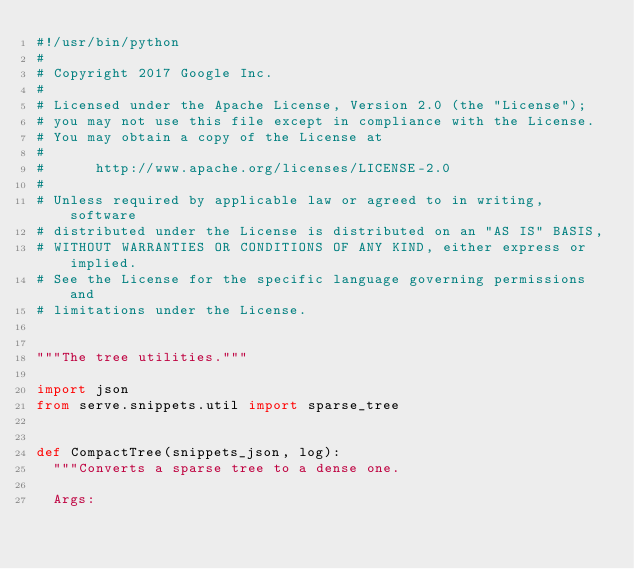Convert code to text. <code><loc_0><loc_0><loc_500><loc_500><_Python_>#!/usr/bin/python
#
# Copyright 2017 Google Inc.
#
# Licensed under the Apache License, Version 2.0 (the "License");
# you may not use this file except in compliance with the License.
# You may obtain a copy of the License at
#
#      http://www.apache.org/licenses/LICENSE-2.0
#
# Unless required by applicable law or agreed to in writing, software
# distributed under the License is distributed on an "AS IS" BASIS,
# WITHOUT WARRANTIES OR CONDITIONS OF ANY KIND, either express or implied.
# See the License for the specific language governing permissions and
# limitations under the License.


"""The tree utilities."""

import json
from serve.snippets.util import sparse_tree


def CompactTree(snippets_json, log):
  """Converts a sparse tree to a dense one.

  Args:</code> 